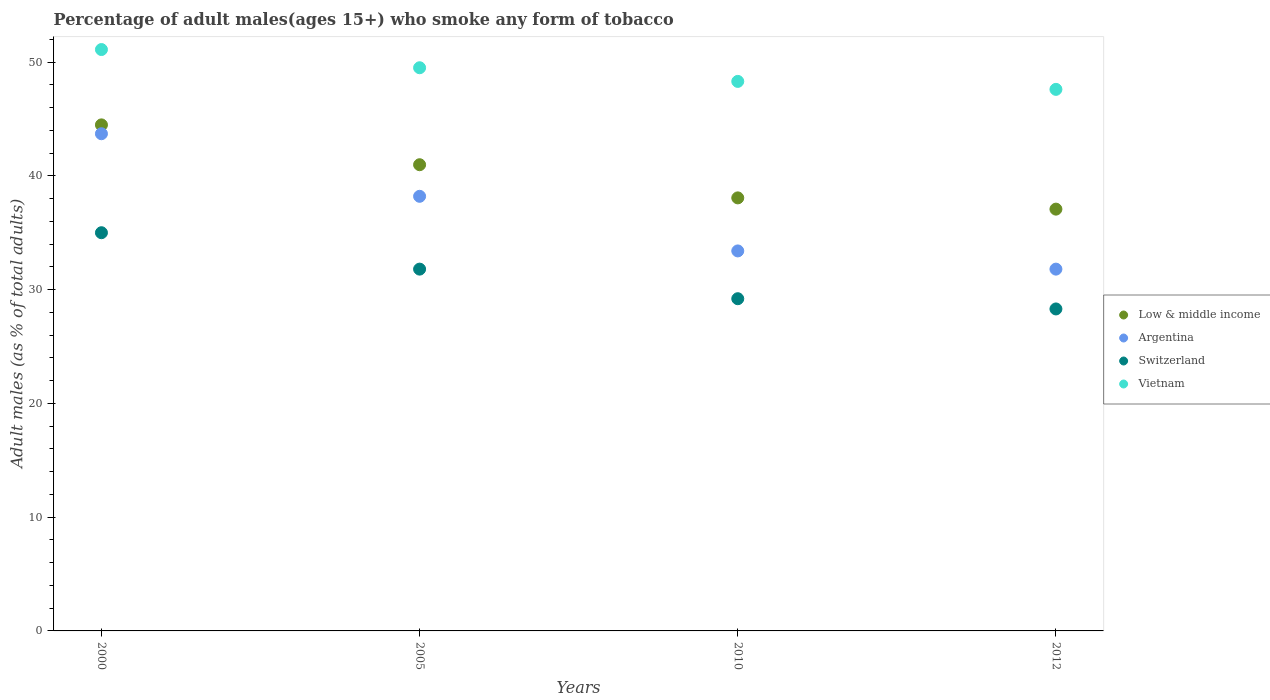How many different coloured dotlines are there?
Your answer should be very brief. 4. What is the percentage of adult males who smoke in Vietnam in 2010?
Offer a terse response. 48.3. Across all years, what is the maximum percentage of adult males who smoke in Low & middle income?
Your answer should be very brief. 44.48. Across all years, what is the minimum percentage of adult males who smoke in Vietnam?
Offer a very short reply. 47.6. What is the total percentage of adult males who smoke in Argentina in the graph?
Provide a short and direct response. 147.1. What is the difference between the percentage of adult males who smoke in Vietnam in 2000 and that in 2005?
Provide a succinct answer. 1.6. What is the difference between the percentage of adult males who smoke in Low & middle income in 2005 and the percentage of adult males who smoke in Vietnam in 2010?
Give a very brief answer. -7.32. What is the average percentage of adult males who smoke in Vietnam per year?
Your answer should be compact. 49.12. In the year 2000, what is the difference between the percentage of adult males who smoke in Vietnam and percentage of adult males who smoke in Argentina?
Offer a terse response. 7.4. What is the ratio of the percentage of adult males who smoke in Argentina in 2000 to that in 2012?
Give a very brief answer. 1.37. Is the percentage of adult males who smoke in Switzerland in 2000 less than that in 2005?
Make the answer very short. No. What is the difference between the highest and the second highest percentage of adult males who smoke in Vietnam?
Provide a succinct answer. 1.6. What is the difference between the highest and the lowest percentage of adult males who smoke in Argentina?
Your answer should be very brief. 11.9. In how many years, is the percentage of adult males who smoke in Vietnam greater than the average percentage of adult males who smoke in Vietnam taken over all years?
Ensure brevity in your answer.  2. Is it the case that in every year, the sum of the percentage of adult males who smoke in Switzerland and percentage of adult males who smoke in Vietnam  is greater than the sum of percentage of adult males who smoke in Low & middle income and percentage of adult males who smoke in Argentina?
Provide a short and direct response. No. Is it the case that in every year, the sum of the percentage of adult males who smoke in Argentina and percentage of adult males who smoke in Switzerland  is greater than the percentage of adult males who smoke in Vietnam?
Your answer should be very brief. Yes. How many dotlines are there?
Your response must be concise. 4. How many years are there in the graph?
Ensure brevity in your answer.  4. Where does the legend appear in the graph?
Your answer should be compact. Center right. How many legend labels are there?
Offer a terse response. 4. What is the title of the graph?
Give a very brief answer. Percentage of adult males(ages 15+) who smoke any form of tobacco. Does "Guinea-Bissau" appear as one of the legend labels in the graph?
Your answer should be compact. No. What is the label or title of the Y-axis?
Your response must be concise. Adult males (as % of total adults). What is the Adult males (as % of total adults) of Low & middle income in 2000?
Your answer should be very brief. 44.48. What is the Adult males (as % of total adults) of Argentina in 2000?
Give a very brief answer. 43.7. What is the Adult males (as % of total adults) of Vietnam in 2000?
Provide a succinct answer. 51.1. What is the Adult males (as % of total adults) in Low & middle income in 2005?
Offer a terse response. 40.98. What is the Adult males (as % of total adults) in Argentina in 2005?
Your response must be concise. 38.2. What is the Adult males (as % of total adults) of Switzerland in 2005?
Give a very brief answer. 31.8. What is the Adult males (as % of total adults) of Vietnam in 2005?
Provide a succinct answer. 49.5. What is the Adult males (as % of total adults) in Low & middle income in 2010?
Give a very brief answer. 38.06. What is the Adult males (as % of total adults) in Argentina in 2010?
Provide a succinct answer. 33.4. What is the Adult males (as % of total adults) of Switzerland in 2010?
Ensure brevity in your answer.  29.2. What is the Adult males (as % of total adults) in Vietnam in 2010?
Your response must be concise. 48.3. What is the Adult males (as % of total adults) of Low & middle income in 2012?
Offer a very short reply. 37.07. What is the Adult males (as % of total adults) in Argentina in 2012?
Offer a very short reply. 31.8. What is the Adult males (as % of total adults) of Switzerland in 2012?
Your response must be concise. 28.3. What is the Adult males (as % of total adults) in Vietnam in 2012?
Your answer should be very brief. 47.6. Across all years, what is the maximum Adult males (as % of total adults) of Low & middle income?
Give a very brief answer. 44.48. Across all years, what is the maximum Adult males (as % of total adults) of Argentina?
Your answer should be compact. 43.7. Across all years, what is the maximum Adult males (as % of total adults) in Vietnam?
Your response must be concise. 51.1. Across all years, what is the minimum Adult males (as % of total adults) of Low & middle income?
Your response must be concise. 37.07. Across all years, what is the minimum Adult males (as % of total adults) in Argentina?
Ensure brevity in your answer.  31.8. Across all years, what is the minimum Adult males (as % of total adults) in Switzerland?
Give a very brief answer. 28.3. Across all years, what is the minimum Adult males (as % of total adults) in Vietnam?
Give a very brief answer. 47.6. What is the total Adult males (as % of total adults) of Low & middle income in the graph?
Keep it short and to the point. 160.59. What is the total Adult males (as % of total adults) in Argentina in the graph?
Your response must be concise. 147.1. What is the total Adult males (as % of total adults) of Switzerland in the graph?
Keep it short and to the point. 124.3. What is the total Adult males (as % of total adults) in Vietnam in the graph?
Offer a very short reply. 196.5. What is the difference between the Adult males (as % of total adults) in Low & middle income in 2000 and that in 2005?
Your answer should be very brief. 3.5. What is the difference between the Adult males (as % of total adults) of Argentina in 2000 and that in 2005?
Your response must be concise. 5.5. What is the difference between the Adult males (as % of total adults) of Vietnam in 2000 and that in 2005?
Provide a succinct answer. 1.6. What is the difference between the Adult males (as % of total adults) of Low & middle income in 2000 and that in 2010?
Make the answer very short. 6.42. What is the difference between the Adult males (as % of total adults) of Argentina in 2000 and that in 2010?
Provide a short and direct response. 10.3. What is the difference between the Adult males (as % of total adults) in Switzerland in 2000 and that in 2010?
Ensure brevity in your answer.  5.8. What is the difference between the Adult males (as % of total adults) of Low & middle income in 2000 and that in 2012?
Your response must be concise. 7.41. What is the difference between the Adult males (as % of total adults) of Switzerland in 2000 and that in 2012?
Your response must be concise. 6.7. What is the difference between the Adult males (as % of total adults) of Low & middle income in 2005 and that in 2010?
Offer a very short reply. 2.91. What is the difference between the Adult males (as % of total adults) of Vietnam in 2005 and that in 2010?
Your answer should be compact. 1.2. What is the difference between the Adult males (as % of total adults) of Low & middle income in 2005 and that in 2012?
Your answer should be very brief. 3.9. What is the difference between the Adult males (as % of total adults) of Argentina in 2005 and that in 2012?
Offer a terse response. 6.4. What is the difference between the Adult males (as % of total adults) of Switzerland in 2005 and that in 2012?
Make the answer very short. 3.5. What is the difference between the Adult males (as % of total adults) in Low & middle income in 2010 and that in 2012?
Make the answer very short. 0.99. What is the difference between the Adult males (as % of total adults) of Argentina in 2010 and that in 2012?
Offer a very short reply. 1.6. What is the difference between the Adult males (as % of total adults) in Switzerland in 2010 and that in 2012?
Provide a short and direct response. 0.9. What is the difference between the Adult males (as % of total adults) of Vietnam in 2010 and that in 2012?
Your answer should be very brief. 0.7. What is the difference between the Adult males (as % of total adults) of Low & middle income in 2000 and the Adult males (as % of total adults) of Argentina in 2005?
Keep it short and to the point. 6.28. What is the difference between the Adult males (as % of total adults) of Low & middle income in 2000 and the Adult males (as % of total adults) of Switzerland in 2005?
Give a very brief answer. 12.68. What is the difference between the Adult males (as % of total adults) of Low & middle income in 2000 and the Adult males (as % of total adults) of Vietnam in 2005?
Your response must be concise. -5.02. What is the difference between the Adult males (as % of total adults) in Argentina in 2000 and the Adult males (as % of total adults) in Switzerland in 2005?
Offer a terse response. 11.9. What is the difference between the Adult males (as % of total adults) of Low & middle income in 2000 and the Adult males (as % of total adults) of Argentina in 2010?
Your answer should be compact. 11.08. What is the difference between the Adult males (as % of total adults) of Low & middle income in 2000 and the Adult males (as % of total adults) of Switzerland in 2010?
Your answer should be very brief. 15.28. What is the difference between the Adult males (as % of total adults) in Low & middle income in 2000 and the Adult males (as % of total adults) in Vietnam in 2010?
Provide a succinct answer. -3.82. What is the difference between the Adult males (as % of total adults) of Argentina in 2000 and the Adult males (as % of total adults) of Switzerland in 2010?
Provide a succinct answer. 14.5. What is the difference between the Adult males (as % of total adults) in Argentina in 2000 and the Adult males (as % of total adults) in Vietnam in 2010?
Make the answer very short. -4.6. What is the difference between the Adult males (as % of total adults) of Switzerland in 2000 and the Adult males (as % of total adults) of Vietnam in 2010?
Provide a short and direct response. -13.3. What is the difference between the Adult males (as % of total adults) in Low & middle income in 2000 and the Adult males (as % of total adults) in Argentina in 2012?
Your response must be concise. 12.68. What is the difference between the Adult males (as % of total adults) in Low & middle income in 2000 and the Adult males (as % of total adults) in Switzerland in 2012?
Provide a short and direct response. 16.18. What is the difference between the Adult males (as % of total adults) in Low & middle income in 2000 and the Adult males (as % of total adults) in Vietnam in 2012?
Your answer should be compact. -3.12. What is the difference between the Adult males (as % of total adults) in Low & middle income in 2005 and the Adult males (as % of total adults) in Argentina in 2010?
Provide a short and direct response. 7.58. What is the difference between the Adult males (as % of total adults) of Low & middle income in 2005 and the Adult males (as % of total adults) of Switzerland in 2010?
Your answer should be very brief. 11.78. What is the difference between the Adult males (as % of total adults) of Low & middle income in 2005 and the Adult males (as % of total adults) of Vietnam in 2010?
Keep it short and to the point. -7.32. What is the difference between the Adult males (as % of total adults) of Argentina in 2005 and the Adult males (as % of total adults) of Switzerland in 2010?
Offer a terse response. 9. What is the difference between the Adult males (as % of total adults) in Argentina in 2005 and the Adult males (as % of total adults) in Vietnam in 2010?
Your answer should be compact. -10.1. What is the difference between the Adult males (as % of total adults) in Switzerland in 2005 and the Adult males (as % of total adults) in Vietnam in 2010?
Offer a terse response. -16.5. What is the difference between the Adult males (as % of total adults) of Low & middle income in 2005 and the Adult males (as % of total adults) of Argentina in 2012?
Provide a short and direct response. 9.18. What is the difference between the Adult males (as % of total adults) in Low & middle income in 2005 and the Adult males (as % of total adults) in Switzerland in 2012?
Your answer should be very brief. 12.68. What is the difference between the Adult males (as % of total adults) of Low & middle income in 2005 and the Adult males (as % of total adults) of Vietnam in 2012?
Ensure brevity in your answer.  -6.62. What is the difference between the Adult males (as % of total adults) in Argentina in 2005 and the Adult males (as % of total adults) in Switzerland in 2012?
Keep it short and to the point. 9.9. What is the difference between the Adult males (as % of total adults) of Switzerland in 2005 and the Adult males (as % of total adults) of Vietnam in 2012?
Give a very brief answer. -15.8. What is the difference between the Adult males (as % of total adults) of Low & middle income in 2010 and the Adult males (as % of total adults) of Argentina in 2012?
Offer a terse response. 6.26. What is the difference between the Adult males (as % of total adults) in Low & middle income in 2010 and the Adult males (as % of total adults) in Switzerland in 2012?
Give a very brief answer. 9.76. What is the difference between the Adult males (as % of total adults) of Low & middle income in 2010 and the Adult males (as % of total adults) of Vietnam in 2012?
Provide a short and direct response. -9.54. What is the difference between the Adult males (as % of total adults) of Argentina in 2010 and the Adult males (as % of total adults) of Switzerland in 2012?
Offer a very short reply. 5.1. What is the difference between the Adult males (as % of total adults) in Switzerland in 2010 and the Adult males (as % of total adults) in Vietnam in 2012?
Make the answer very short. -18.4. What is the average Adult males (as % of total adults) in Low & middle income per year?
Your answer should be very brief. 40.15. What is the average Adult males (as % of total adults) of Argentina per year?
Your answer should be very brief. 36.77. What is the average Adult males (as % of total adults) in Switzerland per year?
Ensure brevity in your answer.  31.07. What is the average Adult males (as % of total adults) in Vietnam per year?
Provide a succinct answer. 49.12. In the year 2000, what is the difference between the Adult males (as % of total adults) of Low & middle income and Adult males (as % of total adults) of Argentina?
Your answer should be very brief. 0.78. In the year 2000, what is the difference between the Adult males (as % of total adults) in Low & middle income and Adult males (as % of total adults) in Switzerland?
Your answer should be compact. 9.48. In the year 2000, what is the difference between the Adult males (as % of total adults) in Low & middle income and Adult males (as % of total adults) in Vietnam?
Give a very brief answer. -6.62. In the year 2000, what is the difference between the Adult males (as % of total adults) in Argentina and Adult males (as % of total adults) in Switzerland?
Offer a terse response. 8.7. In the year 2000, what is the difference between the Adult males (as % of total adults) in Switzerland and Adult males (as % of total adults) in Vietnam?
Keep it short and to the point. -16.1. In the year 2005, what is the difference between the Adult males (as % of total adults) in Low & middle income and Adult males (as % of total adults) in Argentina?
Offer a terse response. 2.78. In the year 2005, what is the difference between the Adult males (as % of total adults) in Low & middle income and Adult males (as % of total adults) in Switzerland?
Provide a short and direct response. 9.18. In the year 2005, what is the difference between the Adult males (as % of total adults) in Low & middle income and Adult males (as % of total adults) in Vietnam?
Give a very brief answer. -8.52. In the year 2005, what is the difference between the Adult males (as % of total adults) in Switzerland and Adult males (as % of total adults) in Vietnam?
Make the answer very short. -17.7. In the year 2010, what is the difference between the Adult males (as % of total adults) in Low & middle income and Adult males (as % of total adults) in Argentina?
Your answer should be very brief. 4.66. In the year 2010, what is the difference between the Adult males (as % of total adults) in Low & middle income and Adult males (as % of total adults) in Switzerland?
Give a very brief answer. 8.86. In the year 2010, what is the difference between the Adult males (as % of total adults) in Low & middle income and Adult males (as % of total adults) in Vietnam?
Provide a short and direct response. -10.24. In the year 2010, what is the difference between the Adult males (as % of total adults) in Argentina and Adult males (as % of total adults) in Switzerland?
Your answer should be very brief. 4.2. In the year 2010, what is the difference between the Adult males (as % of total adults) of Argentina and Adult males (as % of total adults) of Vietnam?
Provide a succinct answer. -14.9. In the year 2010, what is the difference between the Adult males (as % of total adults) of Switzerland and Adult males (as % of total adults) of Vietnam?
Give a very brief answer. -19.1. In the year 2012, what is the difference between the Adult males (as % of total adults) in Low & middle income and Adult males (as % of total adults) in Argentina?
Offer a very short reply. 5.27. In the year 2012, what is the difference between the Adult males (as % of total adults) of Low & middle income and Adult males (as % of total adults) of Switzerland?
Your answer should be very brief. 8.77. In the year 2012, what is the difference between the Adult males (as % of total adults) in Low & middle income and Adult males (as % of total adults) in Vietnam?
Ensure brevity in your answer.  -10.53. In the year 2012, what is the difference between the Adult males (as % of total adults) of Argentina and Adult males (as % of total adults) of Vietnam?
Your answer should be very brief. -15.8. In the year 2012, what is the difference between the Adult males (as % of total adults) in Switzerland and Adult males (as % of total adults) in Vietnam?
Give a very brief answer. -19.3. What is the ratio of the Adult males (as % of total adults) of Low & middle income in 2000 to that in 2005?
Your answer should be very brief. 1.09. What is the ratio of the Adult males (as % of total adults) in Argentina in 2000 to that in 2005?
Offer a very short reply. 1.14. What is the ratio of the Adult males (as % of total adults) of Switzerland in 2000 to that in 2005?
Provide a short and direct response. 1.1. What is the ratio of the Adult males (as % of total adults) of Vietnam in 2000 to that in 2005?
Ensure brevity in your answer.  1.03. What is the ratio of the Adult males (as % of total adults) of Low & middle income in 2000 to that in 2010?
Your response must be concise. 1.17. What is the ratio of the Adult males (as % of total adults) in Argentina in 2000 to that in 2010?
Your answer should be compact. 1.31. What is the ratio of the Adult males (as % of total adults) in Switzerland in 2000 to that in 2010?
Your answer should be very brief. 1.2. What is the ratio of the Adult males (as % of total adults) in Vietnam in 2000 to that in 2010?
Offer a terse response. 1.06. What is the ratio of the Adult males (as % of total adults) in Low & middle income in 2000 to that in 2012?
Ensure brevity in your answer.  1.2. What is the ratio of the Adult males (as % of total adults) in Argentina in 2000 to that in 2012?
Provide a succinct answer. 1.37. What is the ratio of the Adult males (as % of total adults) in Switzerland in 2000 to that in 2012?
Your answer should be compact. 1.24. What is the ratio of the Adult males (as % of total adults) in Vietnam in 2000 to that in 2012?
Offer a terse response. 1.07. What is the ratio of the Adult males (as % of total adults) in Low & middle income in 2005 to that in 2010?
Ensure brevity in your answer.  1.08. What is the ratio of the Adult males (as % of total adults) of Argentina in 2005 to that in 2010?
Your response must be concise. 1.14. What is the ratio of the Adult males (as % of total adults) in Switzerland in 2005 to that in 2010?
Offer a very short reply. 1.09. What is the ratio of the Adult males (as % of total adults) of Vietnam in 2005 to that in 2010?
Provide a short and direct response. 1.02. What is the ratio of the Adult males (as % of total adults) of Low & middle income in 2005 to that in 2012?
Offer a terse response. 1.11. What is the ratio of the Adult males (as % of total adults) of Argentina in 2005 to that in 2012?
Offer a very short reply. 1.2. What is the ratio of the Adult males (as % of total adults) of Switzerland in 2005 to that in 2012?
Your answer should be compact. 1.12. What is the ratio of the Adult males (as % of total adults) in Vietnam in 2005 to that in 2012?
Offer a terse response. 1.04. What is the ratio of the Adult males (as % of total adults) of Low & middle income in 2010 to that in 2012?
Provide a succinct answer. 1.03. What is the ratio of the Adult males (as % of total adults) of Argentina in 2010 to that in 2012?
Offer a terse response. 1.05. What is the ratio of the Adult males (as % of total adults) of Switzerland in 2010 to that in 2012?
Offer a very short reply. 1.03. What is the ratio of the Adult males (as % of total adults) in Vietnam in 2010 to that in 2012?
Provide a succinct answer. 1.01. What is the difference between the highest and the second highest Adult males (as % of total adults) of Low & middle income?
Your answer should be compact. 3.5. What is the difference between the highest and the second highest Adult males (as % of total adults) of Argentina?
Provide a succinct answer. 5.5. What is the difference between the highest and the second highest Adult males (as % of total adults) of Switzerland?
Ensure brevity in your answer.  3.2. What is the difference between the highest and the lowest Adult males (as % of total adults) in Low & middle income?
Give a very brief answer. 7.41. What is the difference between the highest and the lowest Adult males (as % of total adults) in Argentina?
Your answer should be compact. 11.9. What is the difference between the highest and the lowest Adult males (as % of total adults) of Switzerland?
Keep it short and to the point. 6.7. What is the difference between the highest and the lowest Adult males (as % of total adults) in Vietnam?
Provide a succinct answer. 3.5. 